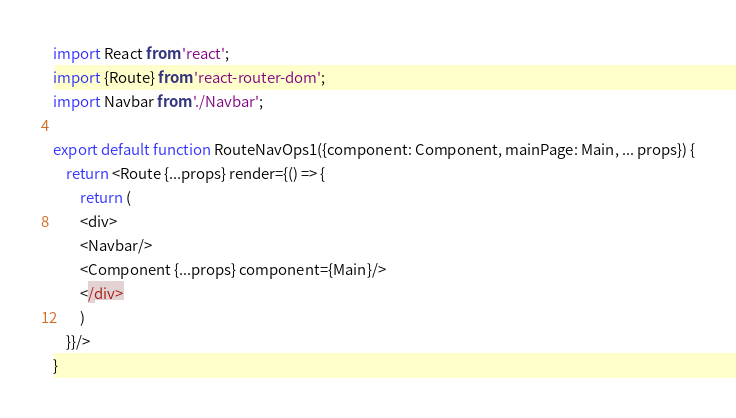<code> <loc_0><loc_0><loc_500><loc_500><_JavaScript_>import React from 'react';
import {Route} from 'react-router-dom';
import Navbar from './Navbar';

export default function RouteNavOps1({component: Component, mainPage: Main, ... props}) {
    return <Route {...props} render={() => {
        return (
        <div>
        <Navbar/>
        <Component {...props} component={Main}/>
        </div>
        )
    }}/>
}
</code> 